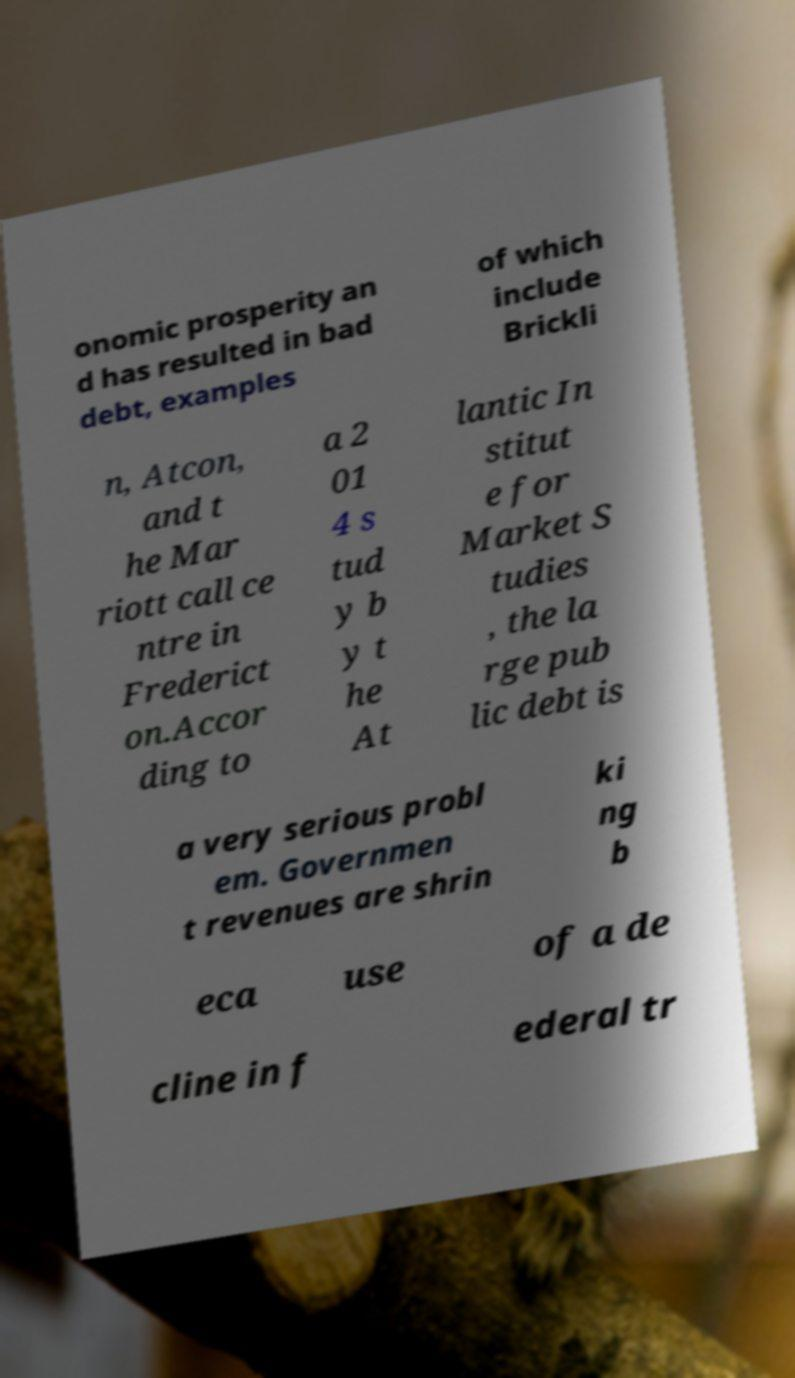There's text embedded in this image that I need extracted. Can you transcribe it verbatim? onomic prosperity an d has resulted in bad debt, examples of which include Brickli n, Atcon, and t he Mar riott call ce ntre in Frederict on.Accor ding to a 2 01 4 s tud y b y t he At lantic In stitut e for Market S tudies , the la rge pub lic debt is a very serious probl em. Governmen t revenues are shrin ki ng b eca use of a de cline in f ederal tr 